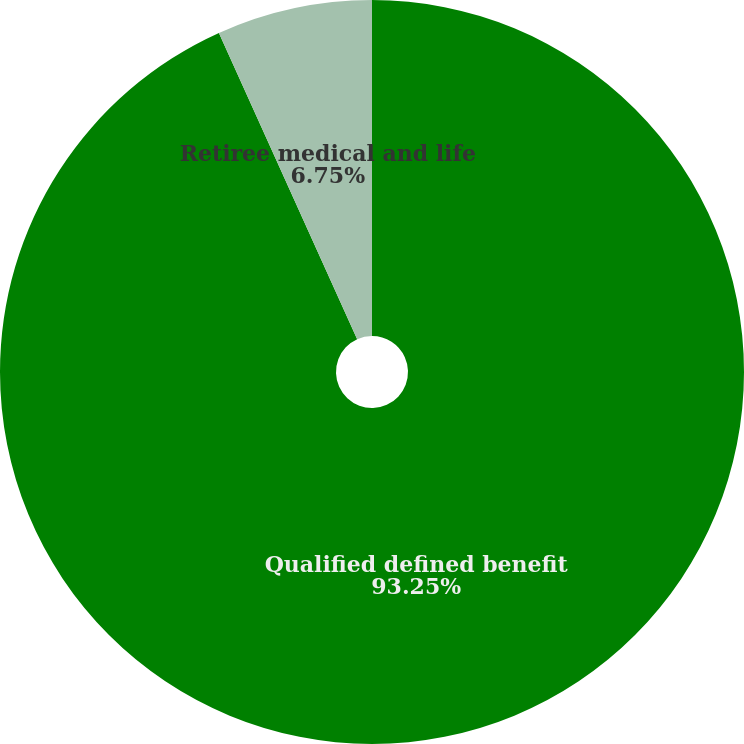<chart> <loc_0><loc_0><loc_500><loc_500><pie_chart><fcel>Qualified defined benefit<fcel>Retiree medical and life<nl><fcel>93.25%<fcel>6.75%<nl></chart> 